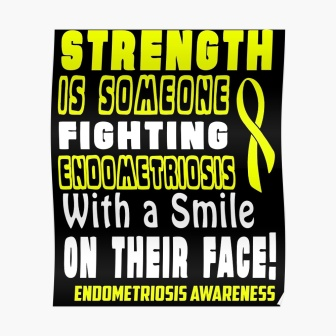What does the yellow ribbon symbolize? The yellow ribbon on the poster is a universal symbol for raising awareness. In this context, it symbolizes endometriosis awareness, representing solidarity and support for those affected by the condition. 